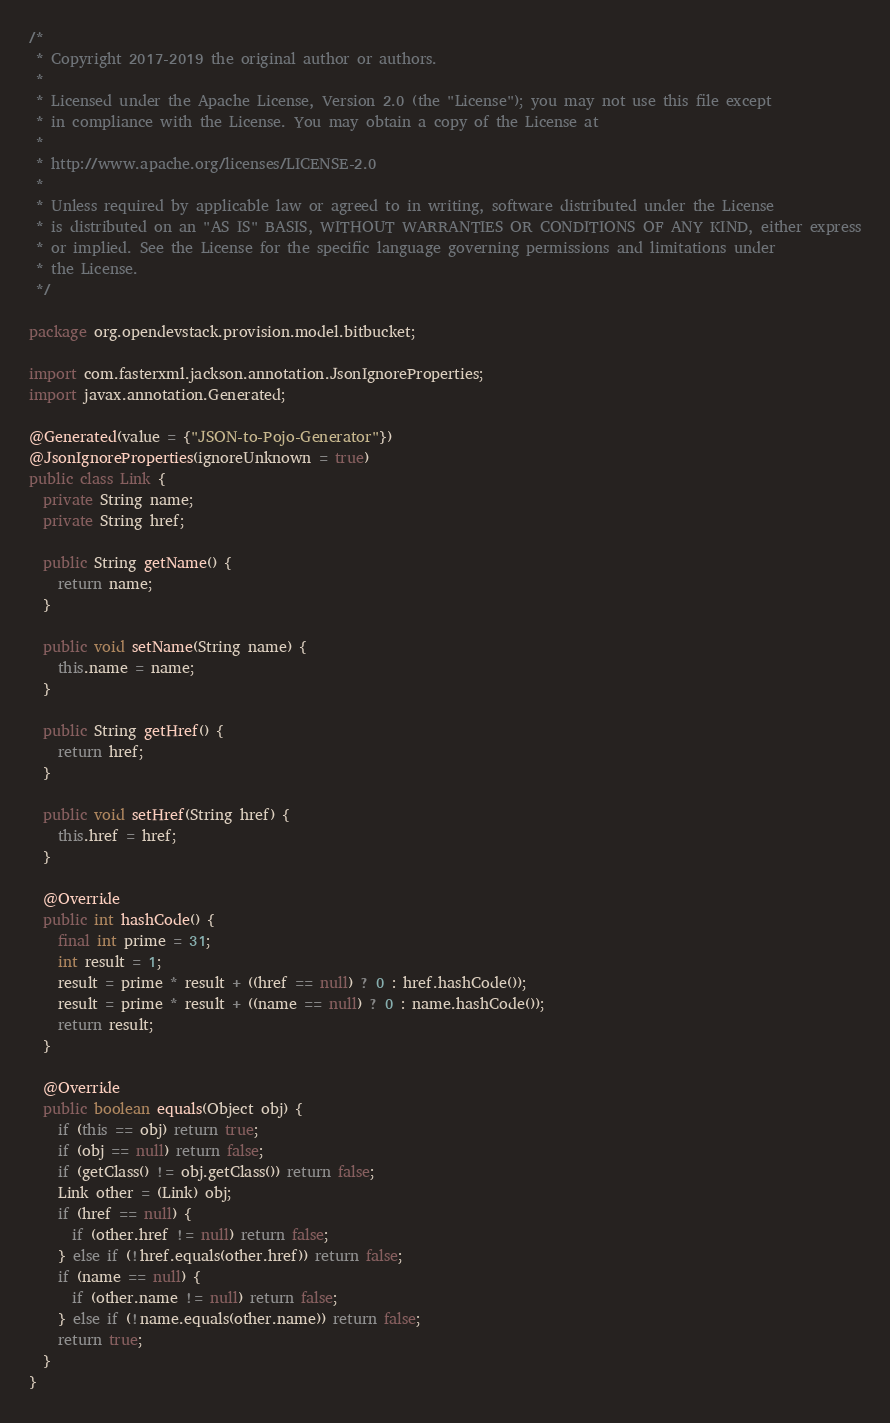Convert code to text. <code><loc_0><loc_0><loc_500><loc_500><_Java_>/*
 * Copyright 2017-2019 the original author or authors.
 *
 * Licensed under the Apache License, Version 2.0 (the "License"); you may not use this file except
 * in compliance with the License. You may obtain a copy of the License at
 *
 * http://www.apache.org/licenses/LICENSE-2.0
 *
 * Unless required by applicable law or agreed to in writing, software distributed under the License
 * is distributed on an "AS IS" BASIS, WITHOUT WARRANTIES OR CONDITIONS OF ANY KIND, either express
 * or implied. See the License for the specific language governing permissions and limitations under
 * the License.
 */

package org.opendevstack.provision.model.bitbucket;

import com.fasterxml.jackson.annotation.JsonIgnoreProperties;
import javax.annotation.Generated;

@Generated(value = {"JSON-to-Pojo-Generator"})
@JsonIgnoreProperties(ignoreUnknown = true)
public class Link {
  private String name;
  private String href;

  public String getName() {
    return name;
  }

  public void setName(String name) {
    this.name = name;
  }

  public String getHref() {
    return href;
  }

  public void setHref(String href) {
    this.href = href;
  }

  @Override
  public int hashCode() {
    final int prime = 31;
    int result = 1;
    result = prime * result + ((href == null) ? 0 : href.hashCode());
    result = prime * result + ((name == null) ? 0 : name.hashCode());
    return result;
  }

  @Override
  public boolean equals(Object obj) {
    if (this == obj) return true;
    if (obj == null) return false;
    if (getClass() != obj.getClass()) return false;
    Link other = (Link) obj;
    if (href == null) {
      if (other.href != null) return false;
    } else if (!href.equals(other.href)) return false;
    if (name == null) {
      if (other.name != null) return false;
    } else if (!name.equals(other.name)) return false;
    return true;
  }
}
</code> 